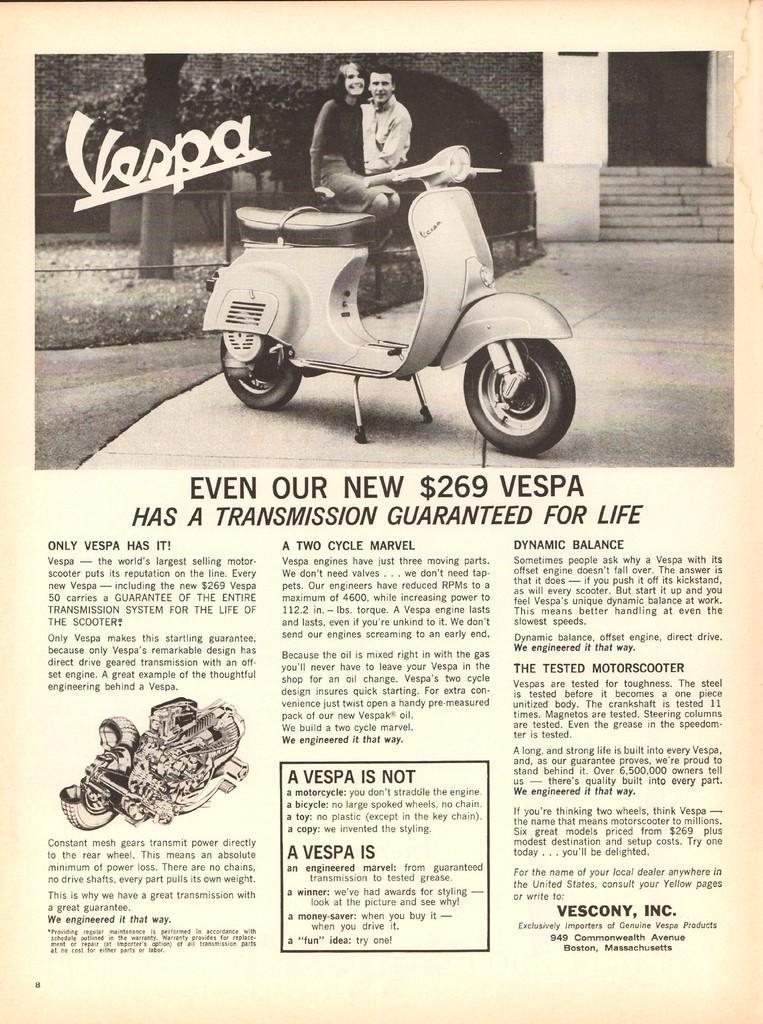In one or two sentences, can you explain what this image depicts? This image consists of a paper. In which we can see a scooter and two persons along with a building. At the bottom, there is text. 